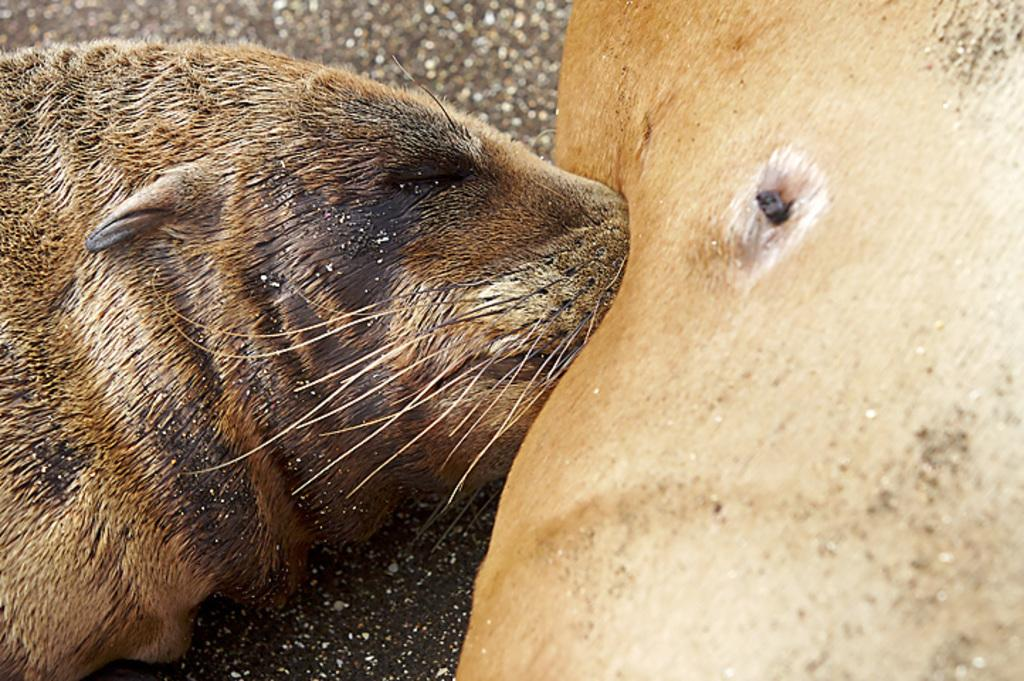What animal is present in the image? There is a seal in the image. What is the position of the seal in the image? The seal is lying on the floor. What type of thing is the seal using to show its leg in the image? There is no indication in the image that the seal is using anything to show its leg, nor is there any "thing" present for that purpose. 